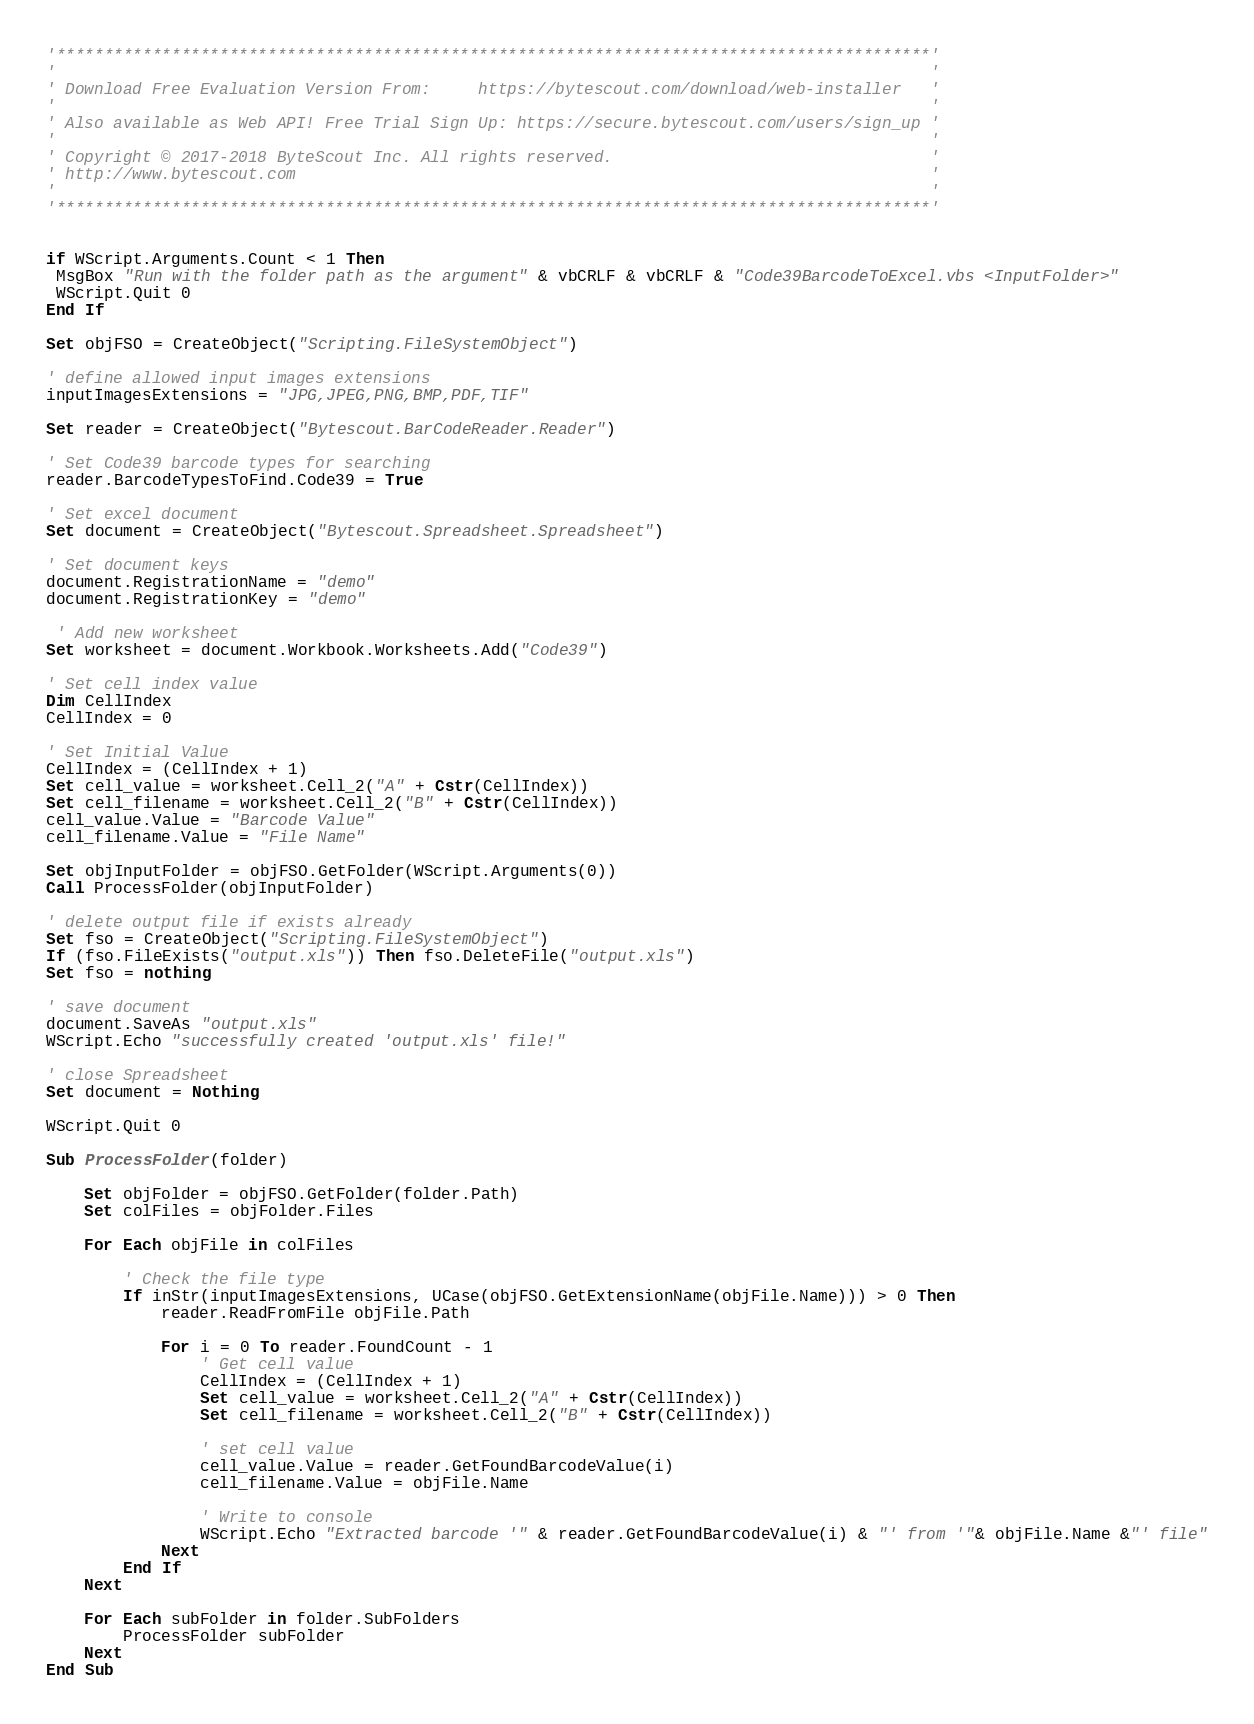Convert code to text. <code><loc_0><loc_0><loc_500><loc_500><_VisualBasic_>'*******************************************************************************************'
'                                                                                           '
' Download Free Evaluation Version From:     https://bytescout.com/download/web-installer   '
'                                                                                           '
' Also available as Web API! Free Trial Sign Up: https://secure.bytescout.com/users/sign_up '
'                                                                                           '
' Copyright © 2017-2018 ByteScout Inc. All rights reserved.                                 '
' http://www.bytescout.com                                                                  '
'                                                                                           '
'*******************************************************************************************'


if WScript.Arguments.Count < 1 Then
 MsgBox "Run with the folder path as the argument" & vbCRLF & vbCRLF & "Code39BarcodeToExcel.vbs <InputFolder>"
 WScript.Quit 0
End If

Set objFSO = CreateObject("Scripting.FileSystemObject")

' define allowed input images extensions
inputImagesExtensions = "JPG,JPEG,PNG,BMP,PDF,TIF"

Set reader = CreateObject("Bytescout.BarCodeReader.Reader")

' Set Code39 barcode types for searching
reader.BarcodeTypesToFind.Code39 = True

' Set excel document
Set document = CreateObject("Bytescout.Spreadsheet.Spreadsheet")

' Set document keys
document.RegistrationName = "demo"
document.RegistrationKey = "demo"

 ' Add new worksheet
Set worksheet = document.Workbook.Worksheets.Add("Code39")

' Set cell index value
Dim CellIndex
CellIndex = 0

' Set Initial Value
CellIndex = (CellIndex + 1) 
Set cell_value = worksheet.Cell_2("A" + Cstr(CellIndex))
Set cell_filename = worksheet.Cell_2("B" + Cstr(CellIndex))
cell_value.Value = "Barcode Value"
cell_filename.Value = "File Name"

Set objInputFolder = objFSO.GetFolder(WScript.Arguments(0))
Call ProcessFolder(objInputFolder)

' delete output file if exists already
Set fso = CreateObject("Scripting.FileSystemObject")
If (fso.FileExists("output.xls")) Then fso.DeleteFile("output.xls")
Set fso = nothing

' save document
document.SaveAs "output.xls"
WScript.Echo "successfully created 'output.xls' file!"

' close Spreadsheet
Set document = Nothing

WScript.Quit 0

Sub ProcessFolder(folder)

    Set objFolder = objFSO.GetFolder(folder.Path)
    Set colFiles = objFolder.Files
    
    For Each objFile in colFiles

        ' Check the file type
        If inStr(inputImagesExtensions, UCase(objFSO.GetExtensionName(objFile.Name))) > 0 Then
			reader.ReadFromFile objFile.Path

			For i = 0 To reader.FoundCount - 1
				' Get cell value
				CellIndex = (CellIndex + 1) 
				Set cell_value = worksheet.Cell_2("A" + Cstr(CellIndex))
				Set cell_filename = worksheet.Cell_2("B" + Cstr(CellIndex))

				' set cell value
				cell_value.Value = reader.GetFoundBarcodeValue(i)
				cell_filename.Value = objFile.Name
				
				' Write to console
				WScript.Echo "Extracted barcode '" & reader.GetFoundBarcodeValue(i) & "' from '"& objFile.Name &"' file"
			Next
        End If
    Next

    For Each subFolder in folder.SubFolders
        ProcessFolder subFolder
    Next
End Sub

</code> 